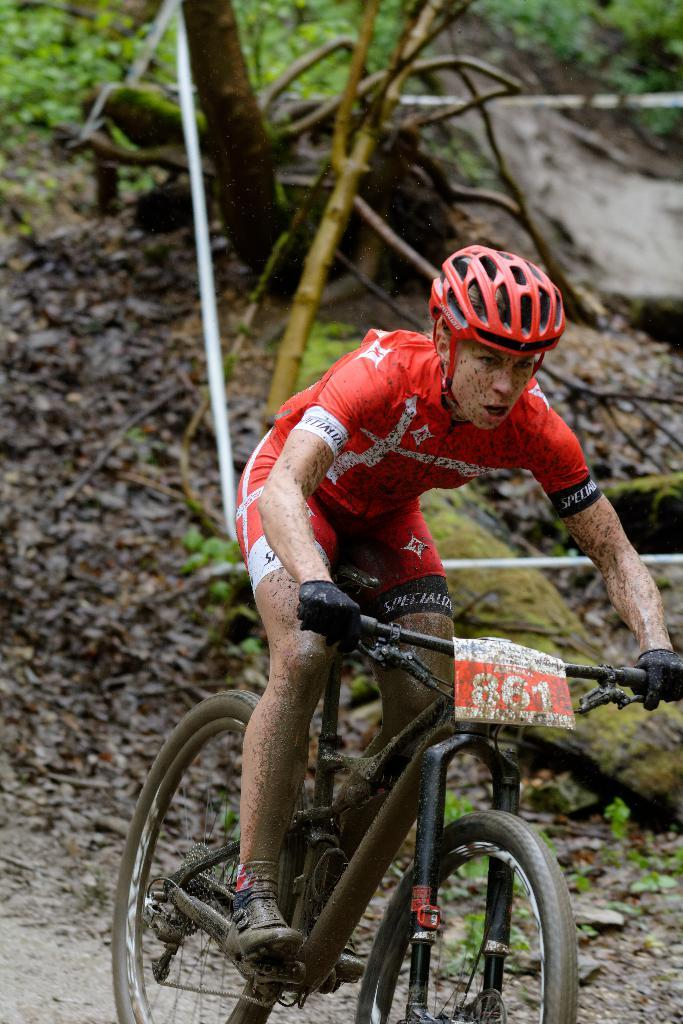What is the person in the image doing? The person is riding a bicycle in the image. What safety gear is the person wearing while riding the bicycle? The person is wearing a red helmet. What can be seen in the background of the image? There are plants and a tree in the background of the image. What is the purpose of the operation being performed by the group in the image? There is no operation or group present in the image; it features a person riding a bicycle with a red helmet and a background of plants and a tree. 